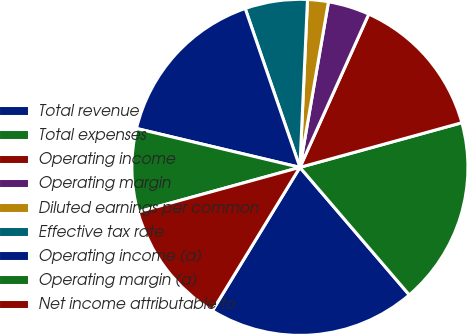<chart> <loc_0><loc_0><loc_500><loc_500><pie_chart><fcel>Total revenue<fcel>Total expenses<fcel>Operating income<fcel>Operating margin<fcel>Diluted earnings per common<fcel>Effective tax rate<fcel>Operating income (a)<fcel>Operating margin (a)<fcel>Net income attributable to<nl><fcel>20.0%<fcel>18.0%<fcel>14.0%<fcel>4.0%<fcel>2.0%<fcel>6.0%<fcel>16.0%<fcel>8.0%<fcel>12.0%<nl></chart> 